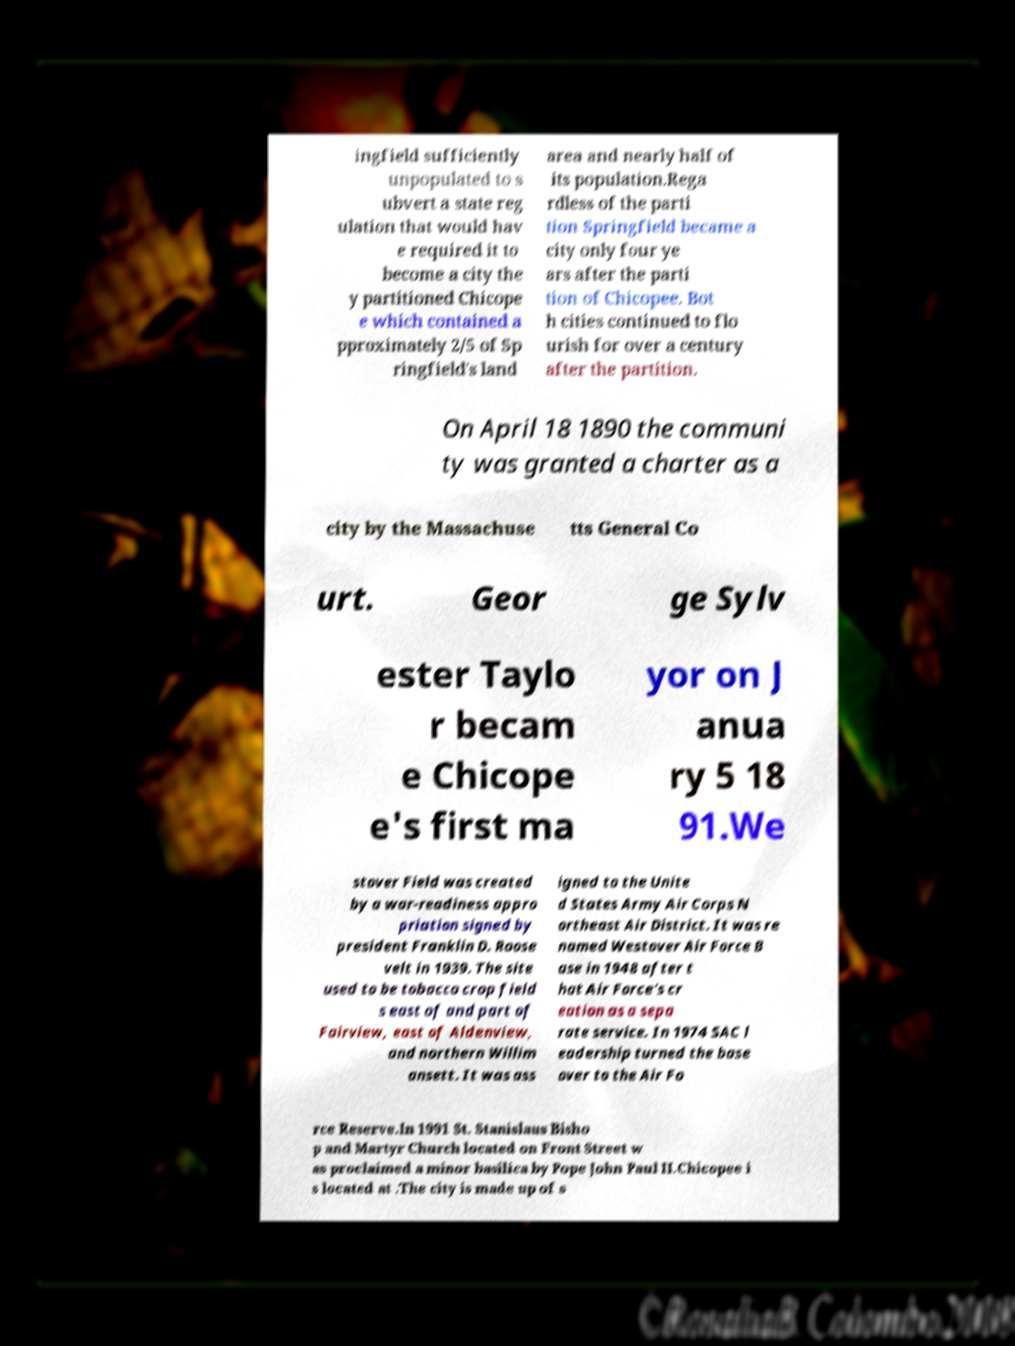Could you extract and type out the text from this image? ingfield sufficiently unpopulated to s ubvert a state reg ulation that would hav e required it to become a city the y partitioned Chicope e which contained a pproximately 2/5 of Sp ringfield's land area and nearly half of its population.Rega rdless of the parti tion Springfield became a city only four ye ars after the parti tion of Chicopee. Bot h cities continued to flo urish for over a century after the partition. On April 18 1890 the communi ty was granted a charter as a city by the Massachuse tts General Co urt. Geor ge Sylv ester Taylo r becam e Chicope e's first ma yor on J anua ry 5 18 91.We stover Field was created by a war-readiness appro priation signed by president Franklin D. Roose velt in 1939. The site used to be tobacco crop field s east of and part of Fairview, east of Aldenview, and northern Willim ansett. It was ass igned to the Unite d States Army Air Corps N ortheast Air District. It was re named Westover Air Force B ase in 1948 after t hat Air Force's cr eation as a sepa rate service. In 1974 SAC l eadership turned the base over to the Air Fo rce Reserve.In 1991 St. Stanislaus Bisho p and Martyr Church located on Front Street w as proclaimed a minor basilica by Pope John Paul II.Chicopee i s located at .The city is made up of s 